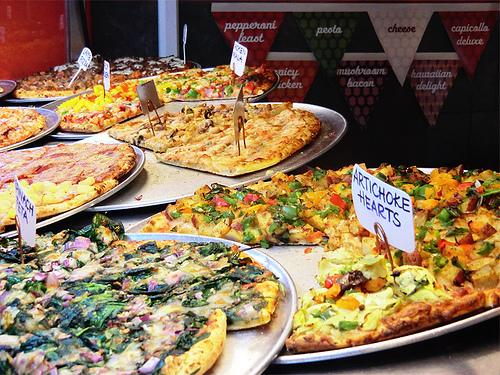Describe the organization and arrangement of the objects in the image. The image presents pizza pies arranged on silver trays with labels in the form of small flags. The flags are placed strategically on the pizzas to identify the toppings. Mention the most visually appealing aspect of the image. The colorful pizza pies with different toppings and labels make for an inviting and appetizing display. Write a sentence mentioning the objects in the image and an adjective describing each one. A variety of appetizing pizza pies are arranged on shiny silver trays, with informative white flags labeling their delicious toppings. List the different toppings mentioned on the small white flags in the image. Artichoke hearts, pesto, cheese, hawaiian delight, mushroom bacon, pepperoni feast, pasta, capicalla deluxe, spicy chicken. Summarize the image with a focus on its main components. The image features an assortment of pizza pies with various toppings, displayed on metal trays and labeled with small flags. Describe the colors and textures you see in the image. The image showcases green spinach, yellow pineapple, and red flags amidst the golden brown crusts and silver metal trays of the pizzas. Imagine you are describing the image to someone who cannot see it. Provide a vivid account. Imagine several pizza pies with a variety of mouth-watering toppings like artichoke hearts and spinach, displayed on gleaming silver trays. Each pizza pie has a small white flag on top, labeling the toppings for easy identification. Explain the purpose of the small white flags in the image. Small white paper flags are standing on the pizzas, serving as labels to identify the different toppings and flavors. Provide a brief description of the scene in the image. Various pizza pies are displayed on silver trays, with small white flags labeling their toppings like artichoke hearts and pesto. Narrate the image from the perspective of a person looking at the display. I see a variety of delicious pizzas laid out on shining silver trays, with the toppings clearly labeled, tempting me to try them all. 